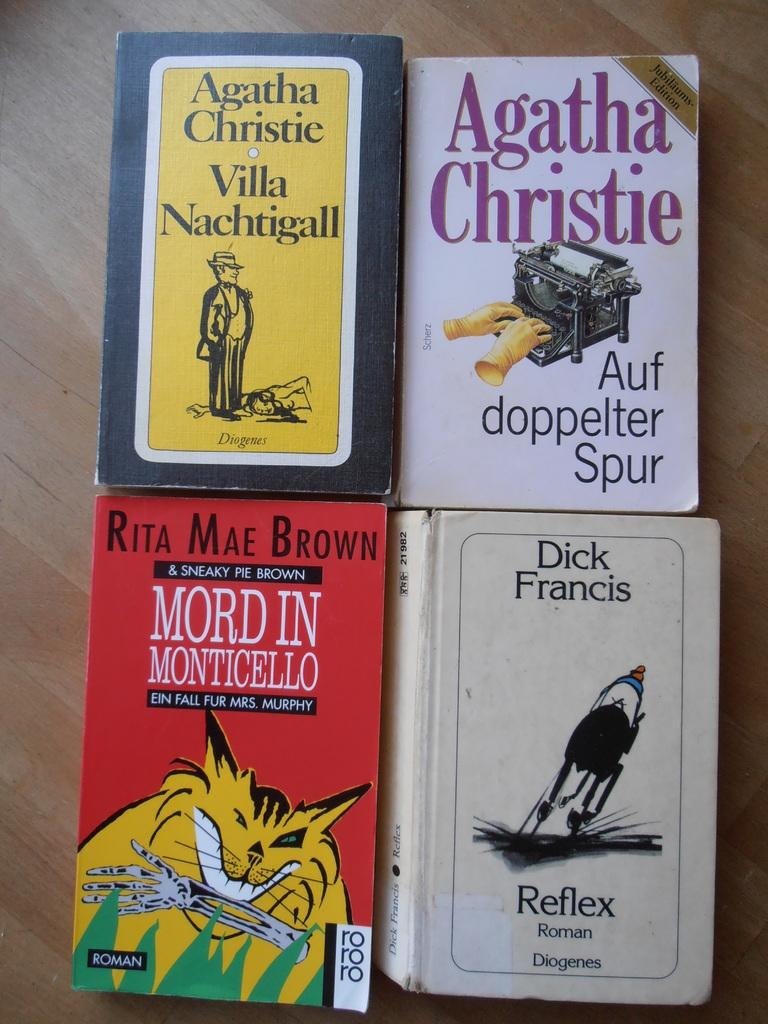<image>
Describe the image concisely. Four mystery, including two Agathy Christie, novels presented on a wooden table 